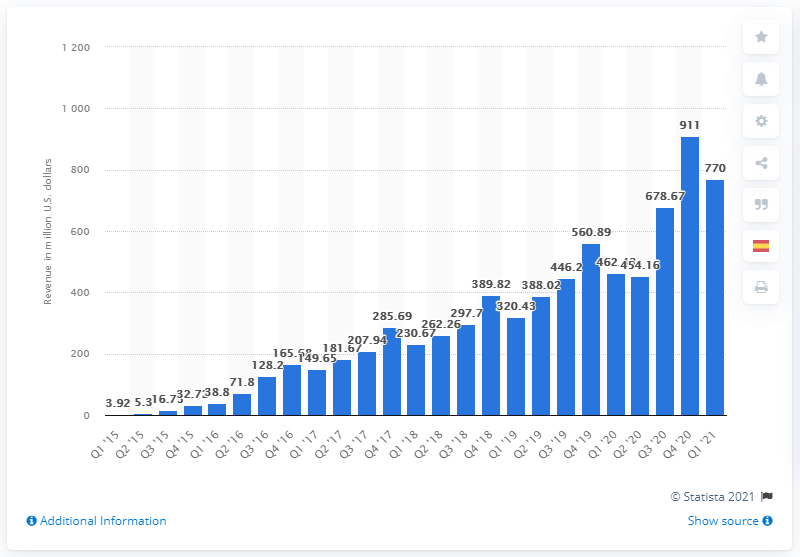Mention a couple of crucial points in this snapshot. In the first quarter of 2021, Snap generated revenue of approximately 770 million dollars. 